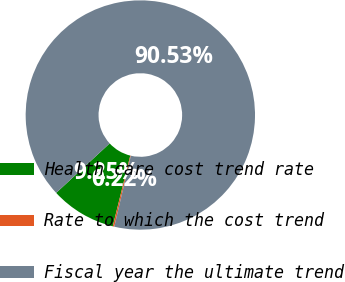Convert chart to OTSL. <chart><loc_0><loc_0><loc_500><loc_500><pie_chart><fcel>Health care cost trend rate<fcel>Rate to which the cost trend<fcel>Fiscal year the ultimate trend<nl><fcel>9.25%<fcel>0.22%<fcel>90.52%<nl></chart> 